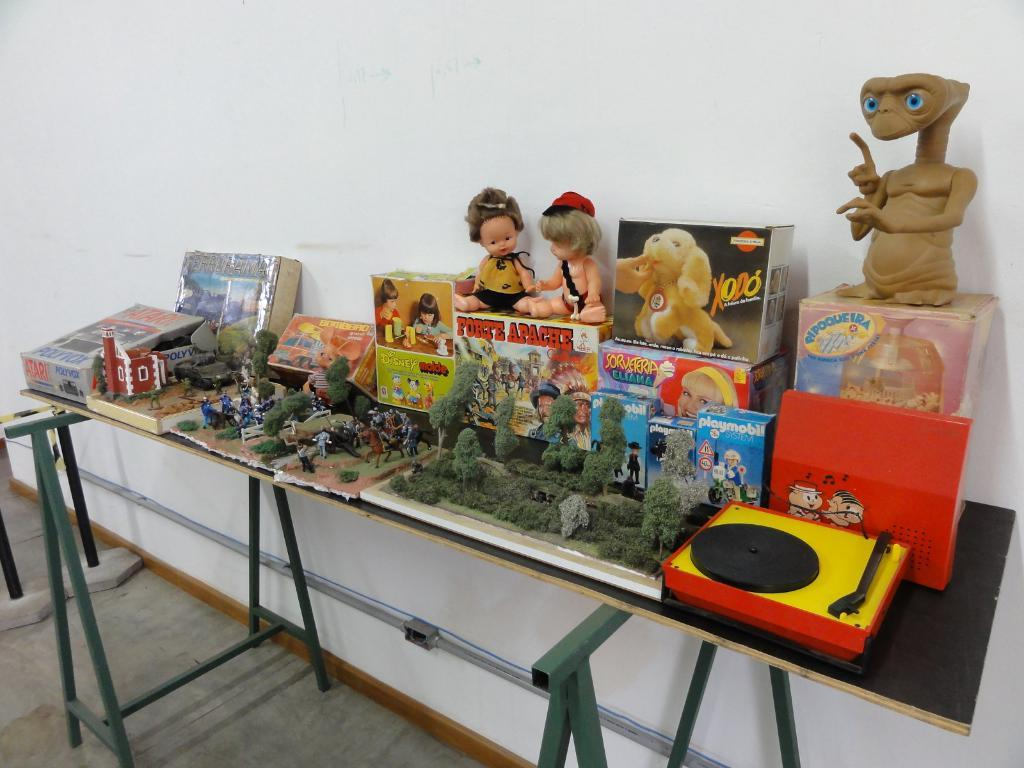<image>
Create a compact narrative representing the image presented. Table full of old toys including one called Forte Apache. 